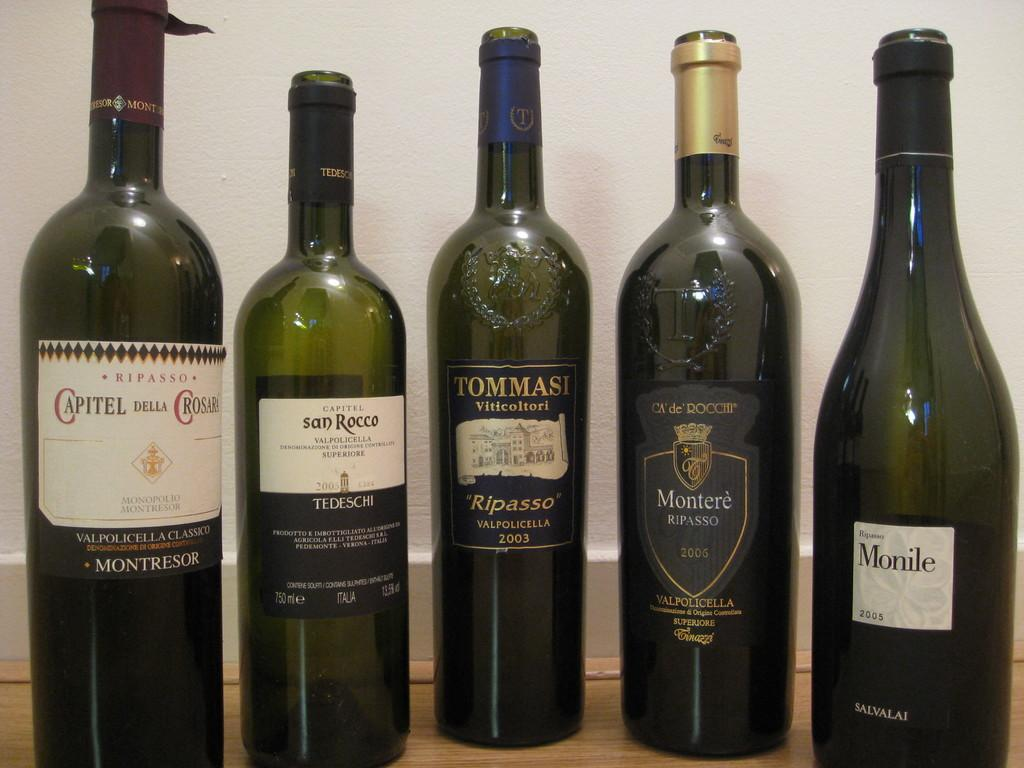<image>
Give a short and clear explanation of the subsequent image. Bottle of Tommasi Ripasso in between some other wine bottles. 